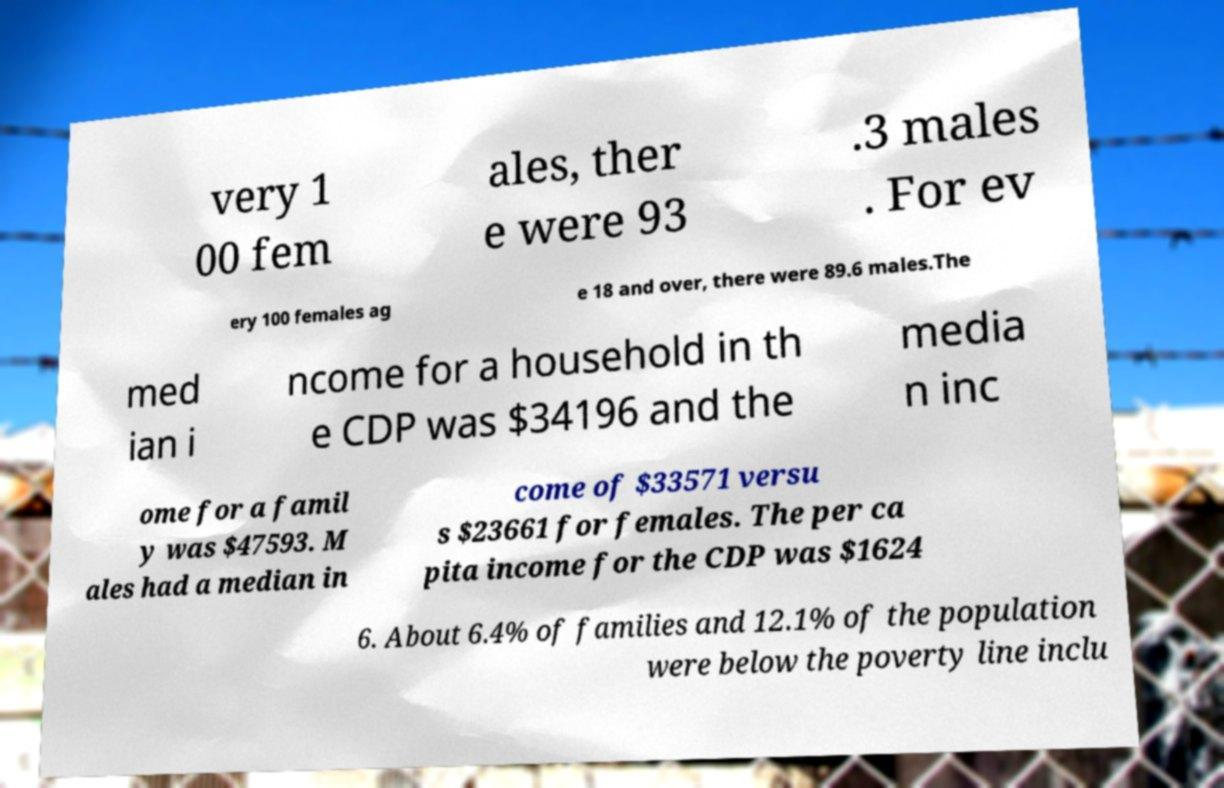For documentation purposes, I need the text within this image transcribed. Could you provide that? very 1 00 fem ales, ther e were 93 .3 males . For ev ery 100 females ag e 18 and over, there were 89.6 males.The med ian i ncome for a household in th e CDP was $34196 and the media n inc ome for a famil y was $47593. M ales had a median in come of $33571 versu s $23661 for females. The per ca pita income for the CDP was $1624 6. About 6.4% of families and 12.1% of the population were below the poverty line inclu 